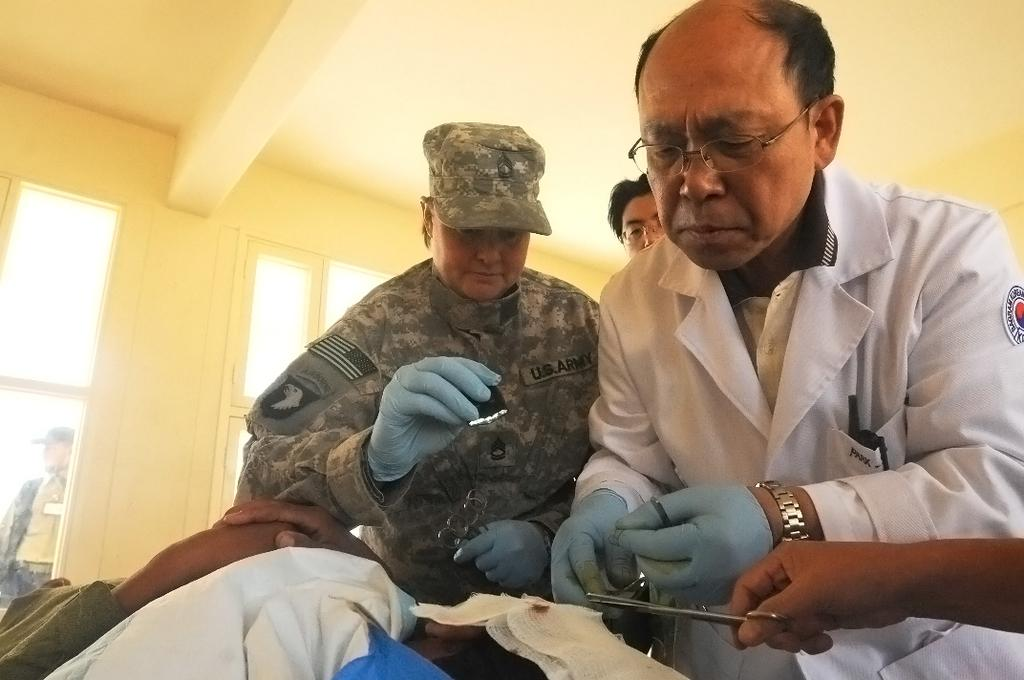What is the position of the person in the image? There is a person laying down in the image. What are the other people in the image doing? There are people standing in the image, and some of them are holding scissors. What can be seen in the background of the image? There is a wall visible in the background of the image. What type of crib is the mother using in the image? There is no crib or mother present in the image. 